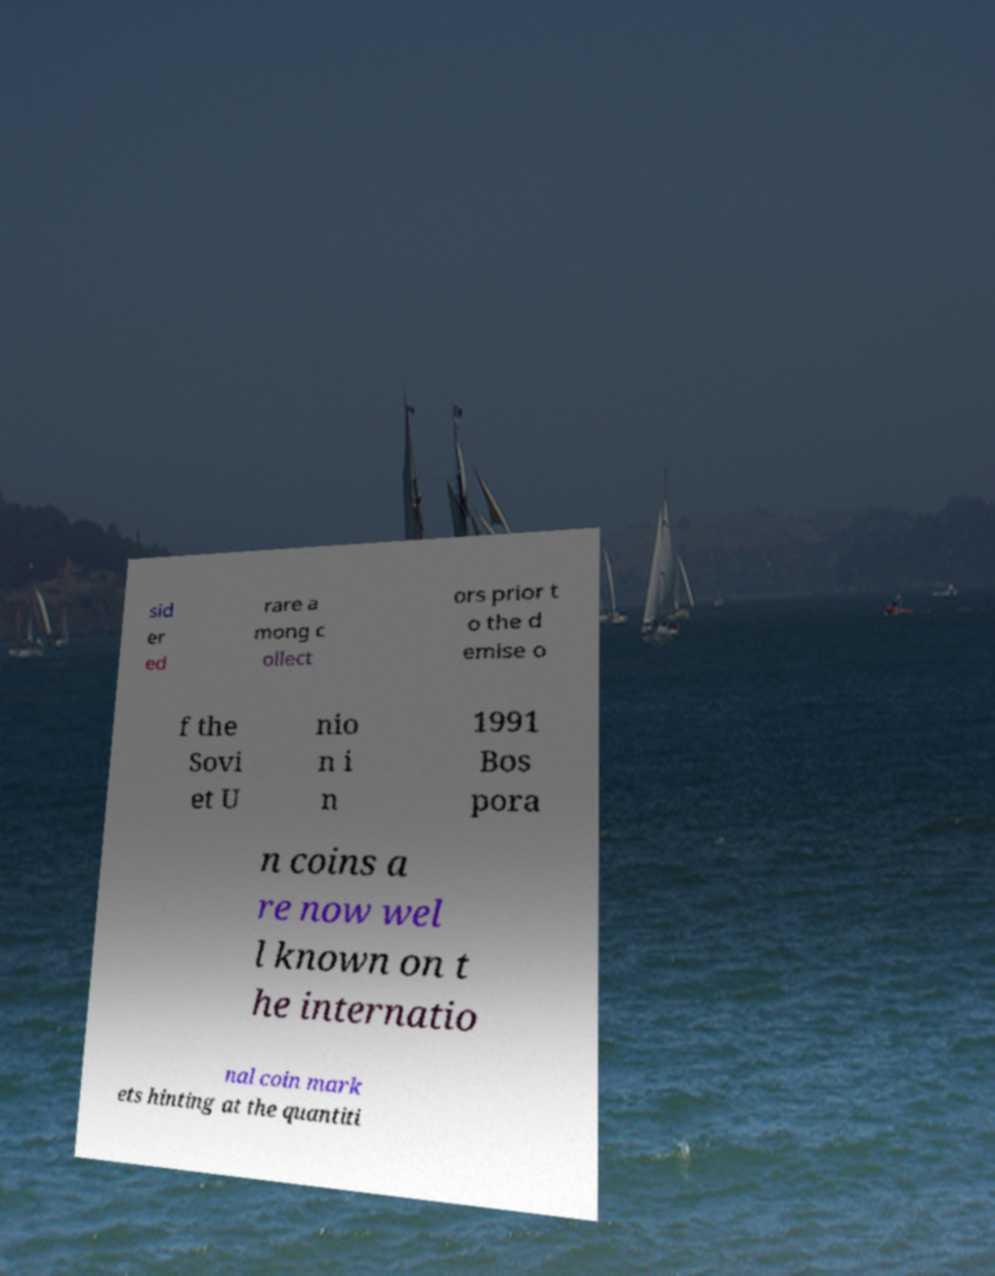I need the written content from this picture converted into text. Can you do that? sid er ed rare a mong c ollect ors prior t o the d emise o f the Sovi et U nio n i n 1991 Bos pora n coins a re now wel l known on t he internatio nal coin mark ets hinting at the quantiti 